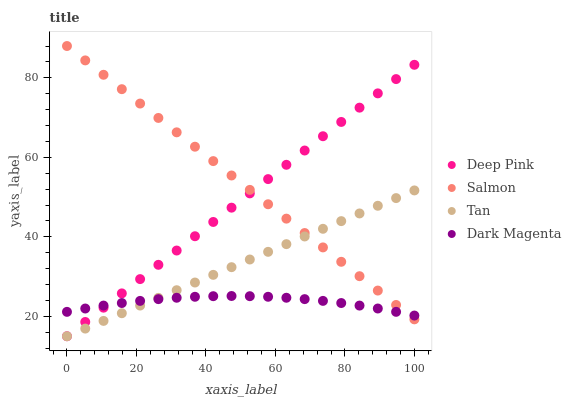Does Dark Magenta have the minimum area under the curve?
Answer yes or no. Yes. Does Salmon have the maximum area under the curve?
Answer yes or no. Yes. Does Deep Pink have the minimum area under the curve?
Answer yes or no. No. Does Deep Pink have the maximum area under the curve?
Answer yes or no. No. Is Tan the smoothest?
Answer yes or no. Yes. Is Dark Magenta the roughest?
Answer yes or no. Yes. Is Deep Pink the smoothest?
Answer yes or no. No. Is Deep Pink the roughest?
Answer yes or no. No. Does Tan have the lowest value?
Answer yes or no. Yes. Does Salmon have the lowest value?
Answer yes or no. No. Does Salmon have the highest value?
Answer yes or no. Yes. Does Deep Pink have the highest value?
Answer yes or no. No. Does Deep Pink intersect Salmon?
Answer yes or no. Yes. Is Deep Pink less than Salmon?
Answer yes or no. No. Is Deep Pink greater than Salmon?
Answer yes or no. No. 